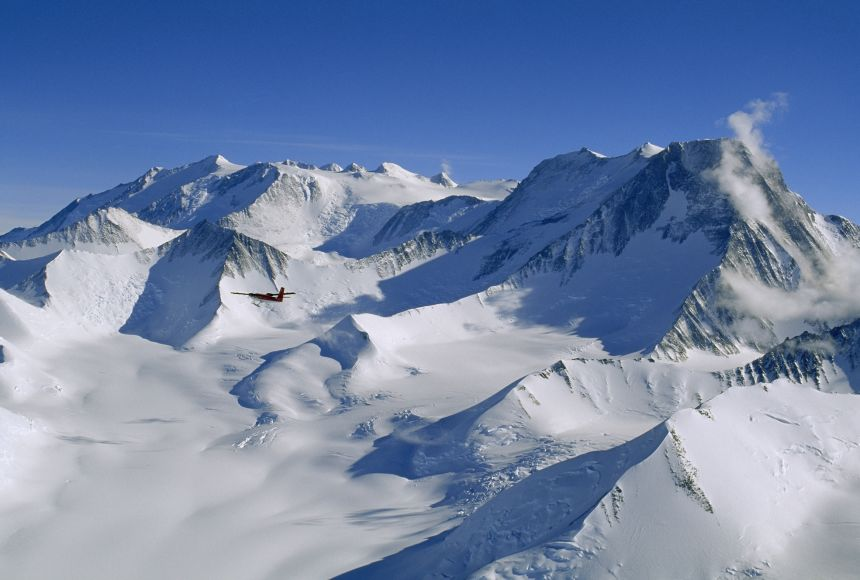What kind of challenges might pilots face while flying over such icy terrains? Flying over icy terrains like those of Vinson Massif involves several challenges including extreme cold, which can affect aircraft mechanical functions; low oxygen levels at high altitudes, which can affect engine performance; and limited visibility due to sudden weather changes, which can include snowstorms or cloud cover. Pilots need specialized training and equipment to navigate these conditions safely. 